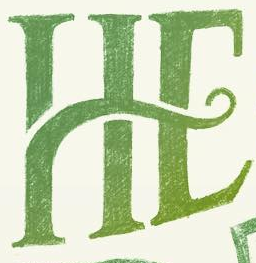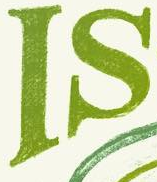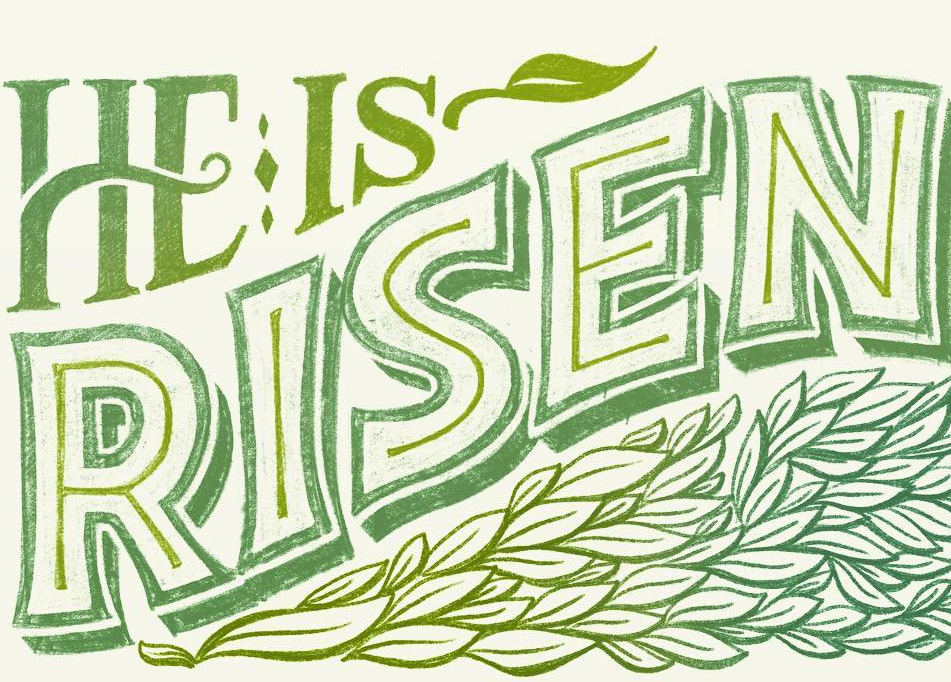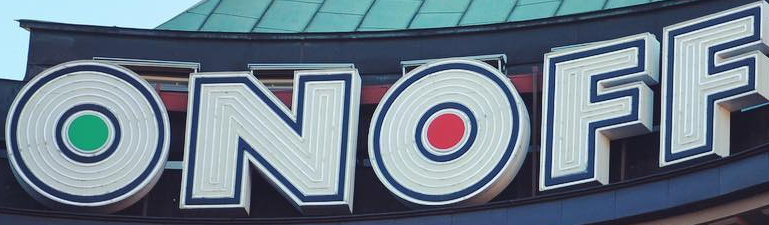What text appears in these images from left to right, separated by a semicolon? HE; IS; RISEN; ONOFF 